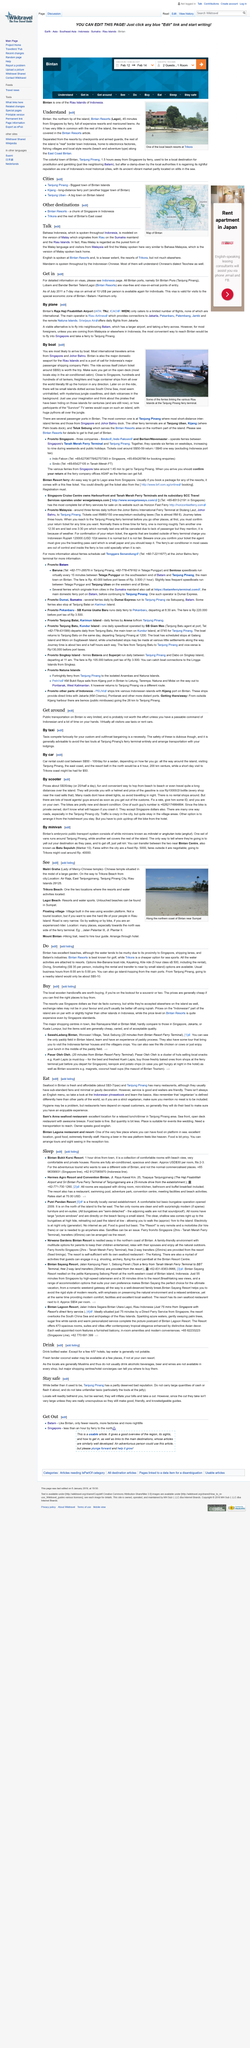List a handful of essential elements in this visual. It is not advisable to travel at night as many roads lack adequate street lighting, posing a significant safety risk. The cost of scooters per day is approximately S$35. What can be seen across the South China Sea are small islands with mysterious jungle coastlines and dark volcanoes in the background, offering a scenic and enigmatic view. The picture was taken at the Tanjung Pinang ferry terminal. It is a fact that virtually all visitors to a certain location use either taxis or rent cars to get around. 